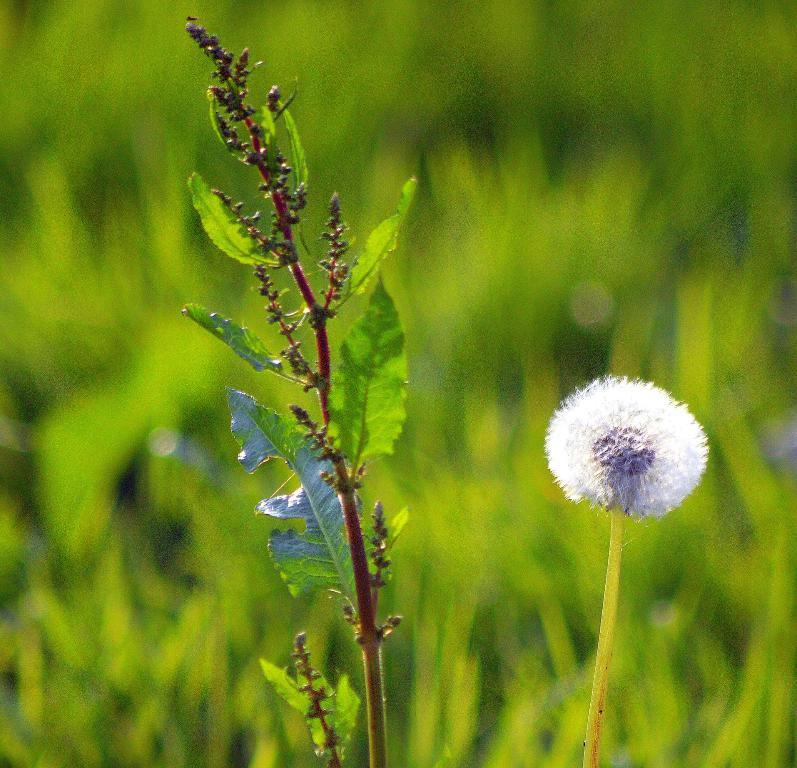What type of plant can be seen in the image? There is a plant in the image. What specific part of the plant is visible? There is a flower in the image. What type of vegetation can be seen in the background of the image? There is grass visible in the background of the image. What type of whip can be seen in the image? There is no whip present in the image. Can you describe the self-awareness of the plant in the image? Plants do not possess self-awareness, so this question cannot be answered. 